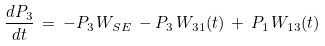<formula> <loc_0><loc_0><loc_500><loc_500>\frac { d P _ { 3 } } { d t } \, = \, - P _ { 3 } \, W _ { S E } \, - P _ { 3 } \, W _ { 3 1 } ( t ) \, + \, P _ { 1 } \, W _ { 1 3 } ( t )</formula> 